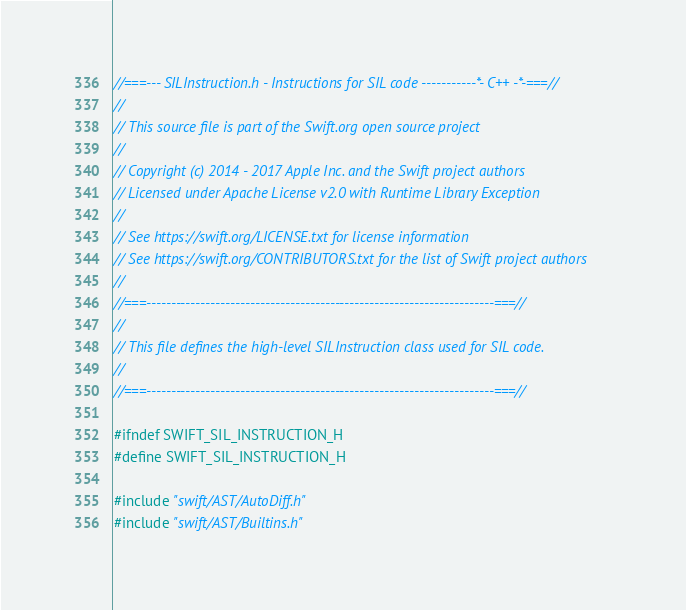Convert code to text. <code><loc_0><loc_0><loc_500><loc_500><_C_>//===--- SILInstruction.h - Instructions for SIL code -----------*- C++ -*-===//
//
// This source file is part of the Swift.org open source project
//
// Copyright (c) 2014 - 2017 Apple Inc. and the Swift project authors
// Licensed under Apache License v2.0 with Runtime Library Exception
//
// See https://swift.org/LICENSE.txt for license information
// See https://swift.org/CONTRIBUTORS.txt for the list of Swift project authors
//
//===----------------------------------------------------------------------===//
//
// This file defines the high-level SILInstruction class used for SIL code.
//
//===----------------------------------------------------------------------===//

#ifndef SWIFT_SIL_INSTRUCTION_H
#define SWIFT_SIL_INSTRUCTION_H

#include "swift/AST/AutoDiff.h"
#include "swift/AST/Builtins.h"</code> 